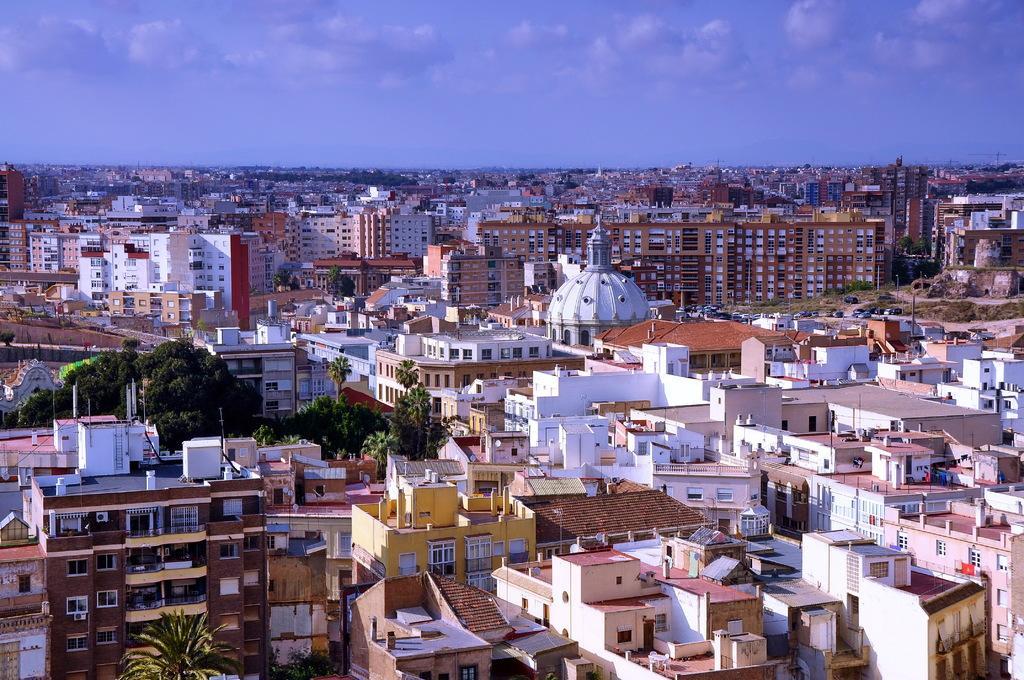How would you summarize this image in a sentence or two? In this picture we can see buildings here, there are some trees, we can see the sky at the top of the picture, we can also see windows of these buildings. 